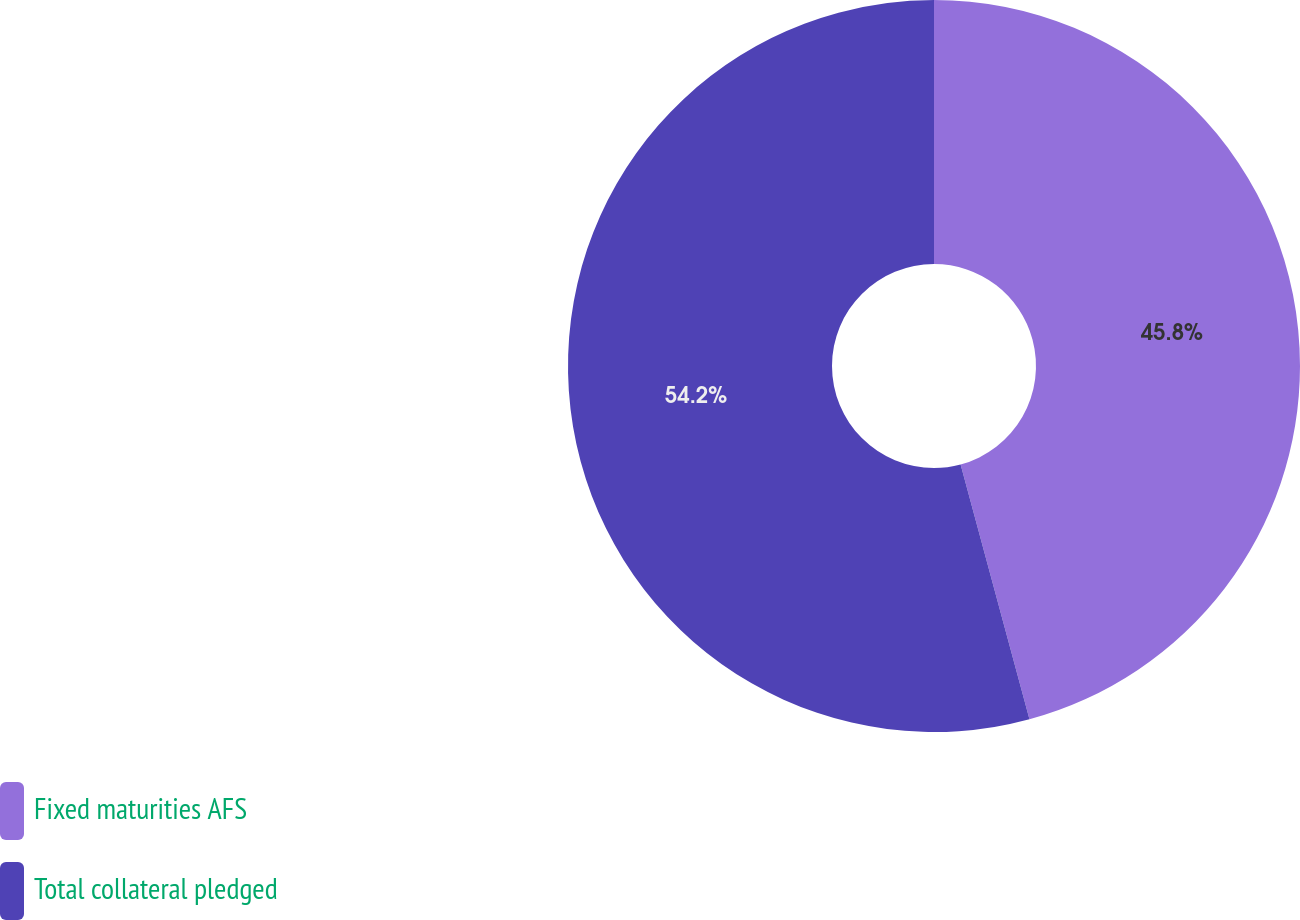Convert chart. <chart><loc_0><loc_0><loc_500><loc_500><pie_chart><fcel>Fixed maturities AFS<fcel>Total collateral pledged<nl><fcel>45.8%<fcel>54.2%<nl></chart> 